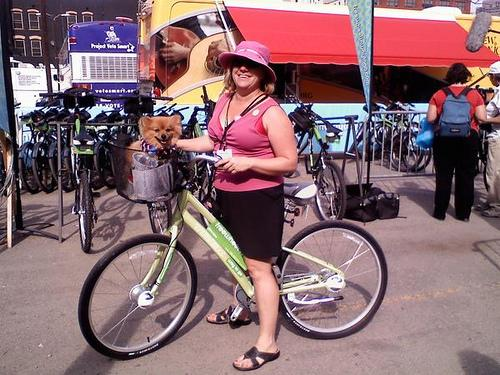What kind of accessory should the woman wear? Please explain your reasoning. sports shoes. The woman should have sneakers to bike. 